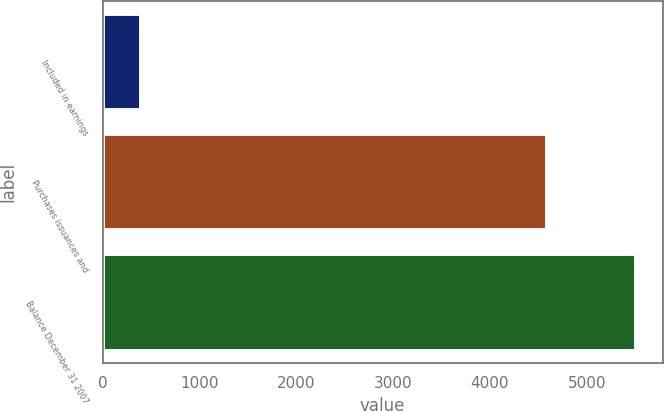Convert chart to OTSL. <chart><loc_0><loc_0><loc_500><loc_500><bar_chart><fcel>Included in earnings<fcel>Purchases issuances and<fcel>Balance December 31 2007<nl><fcel>398<fcel>4588<fcel>5507<nl></chart> 